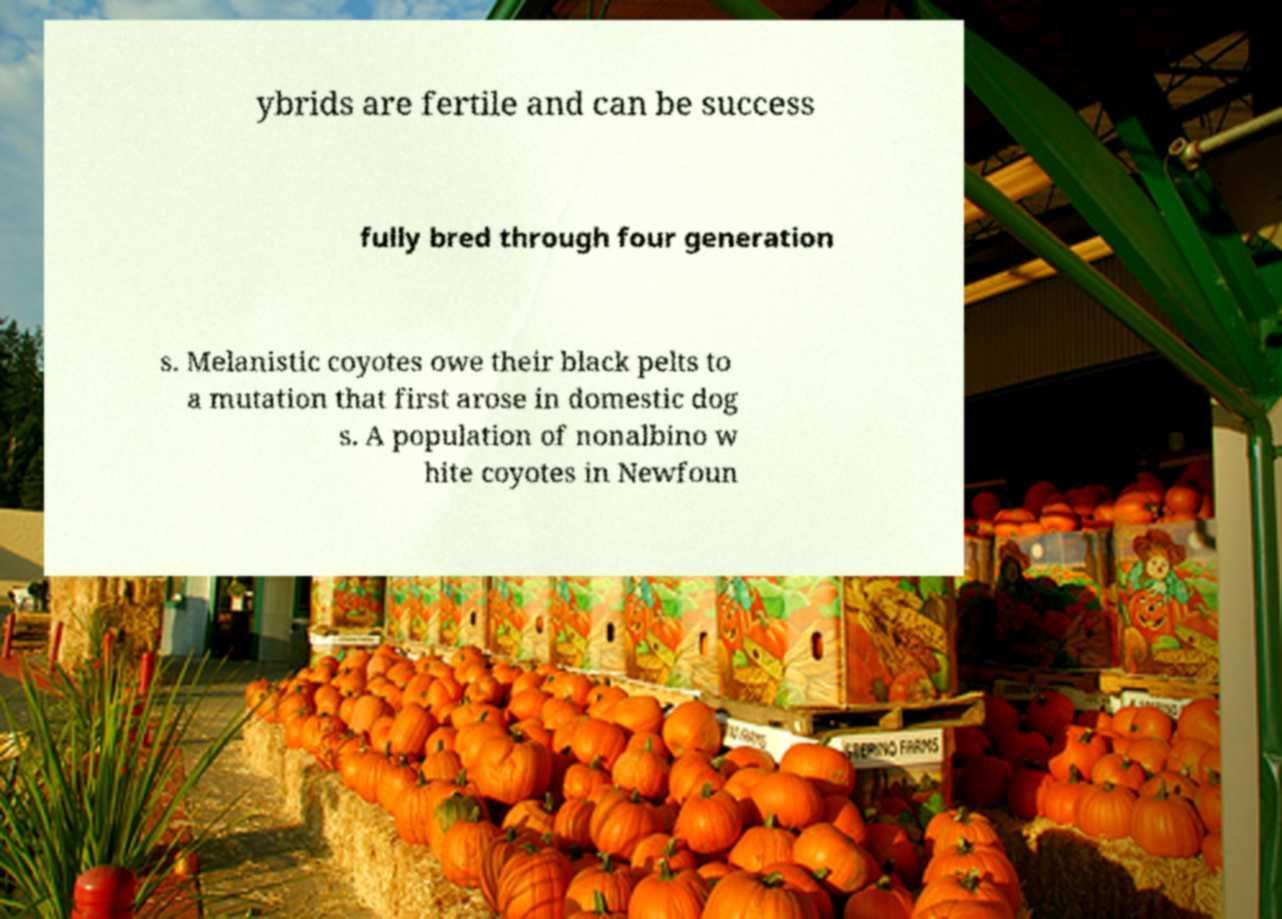Please identify and transcribe the text found in this image. ybrids are fertile and can be success fully bred through four generation s. Melanistic coyotes owe their black pelts to a mutation that first arose in domestic dog s. A population of nonalbino w hite coyotes in Newfoun 